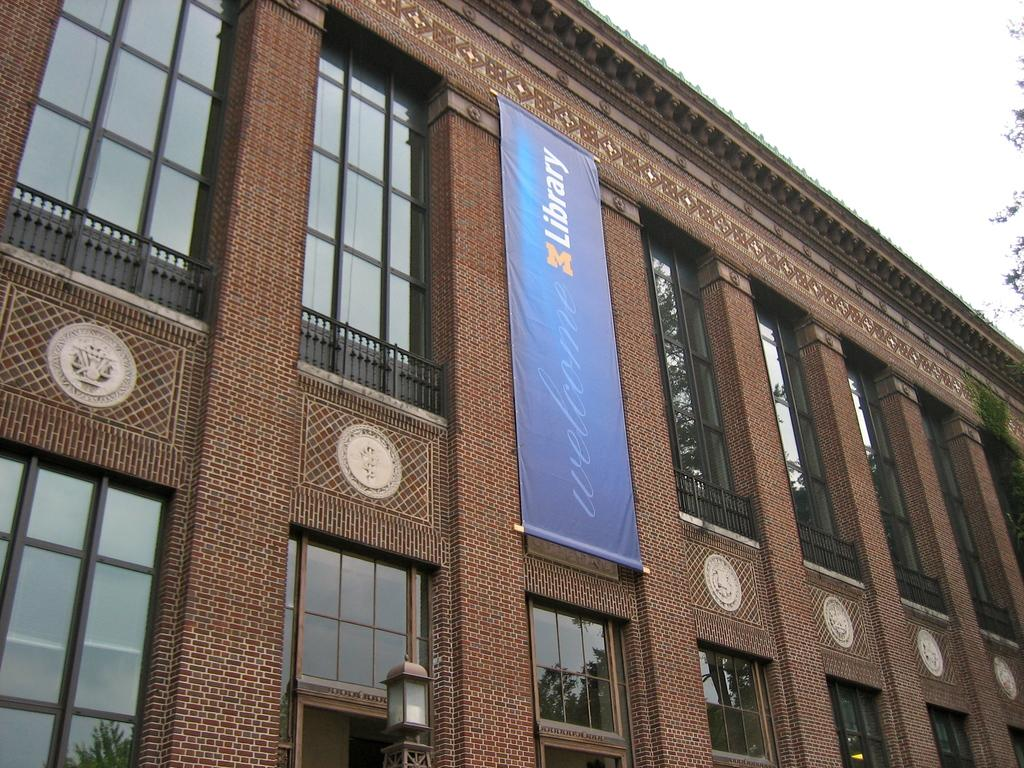<image>
Share a concise interpretation of the image provided. A vertical blue sign on the building reads, "Library." 